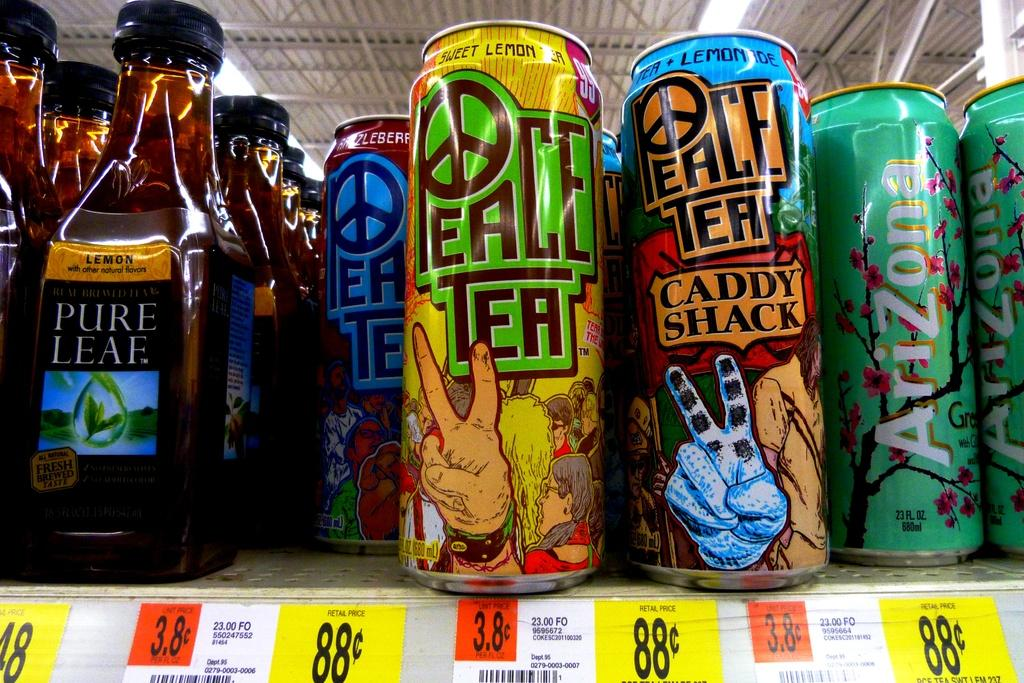<image>
Write a terse but informative summary of the picture. Cans are lined up on a shelf with the brand name Peace Tea. 